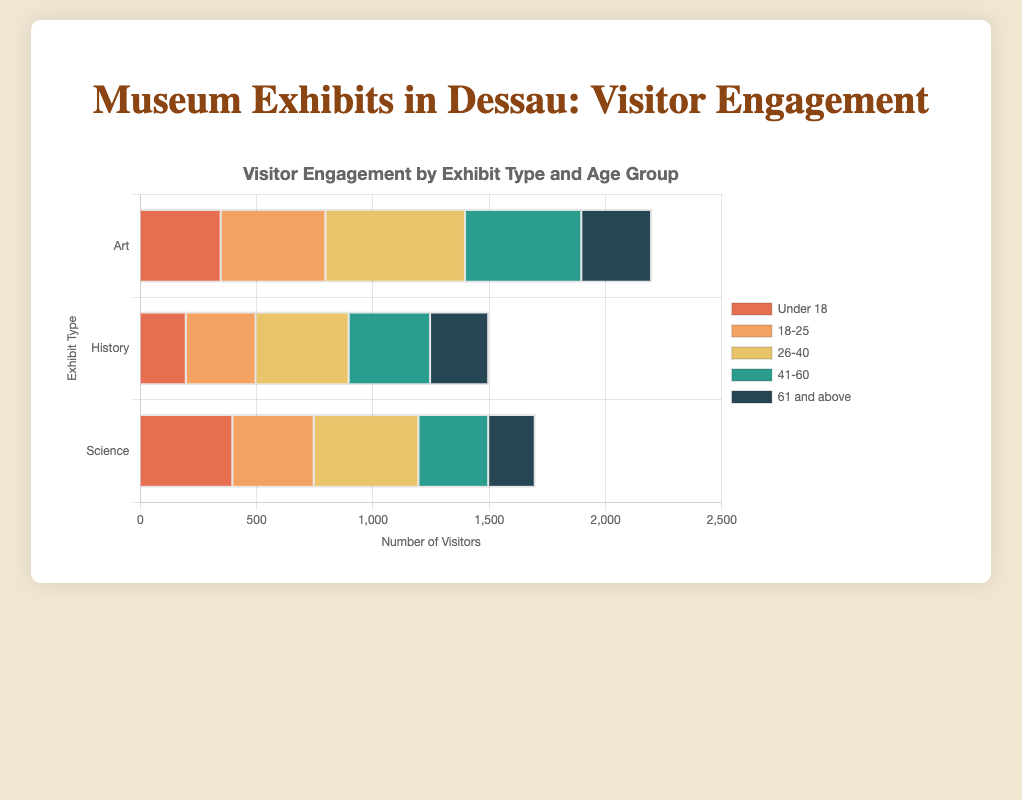What exhibit type has the highest visitor engagement from the '26-40' age group? For the '26-40' age group, compare the visitor numbers for each exhibit type. Art has 600 visitors, History has 400 visitors, and Science has 450 visitors. Therefore, Art has the highest visitor engagement.
Answer: Art How many visitors in total visited the 'Science' exhibits? Sum up the visitor numbers for all age groups in the Science category: 400 (Under 18) + 350 (18-25) + 450 (26-40) + 300 (41-60) + 200 (61 and above) = 1700 visitors.
Answer: 1700 Which exhibit type attracts the most visitors aged '61 and above'? Compare the visitor numbers for the '61 and above' age group across all exhibit types. Art has 300 visitors, History has 250 visitors, and Science has 200 visitors. Art has the most visitors.
Answer: Art What is the total number of visitors for the 'Under 18' age group across all exhibit types? Sum the visitor numbers for the 'Under 18' age group in each exhibit: 350 (Art) + 200 (History) + 400 (Science) = 950 visitors.
Answer: 950 Which age group has the lowest visitor engagement in 'History' exhibits? Compare the visitor numbers for each age group in the History category. Under 18 has 200 visitors, 18-25 has 300 visitors, 26-40 has 400 visitors, 41-60 has 350 visitors, and 61 and above has 250 visitors. Therefore, Under 18 has the lowest engagement.
Answer: Under 18 How many more visitors does the '41-60' age group have in 'Art' exhibits compared to 'Science' exhibits? Calculate the difference in the number of visitors between the two exhibit types for the '41-60' age group. Art has 500 visitors and Science has 300 visitors. The difference is 500 - 300 = 200 more visitors in Art.
Answer: 200 Which color represents the '18-25' age group in the chart? Refer to the color legend for the '18-25' age group. The color is orange.
Answer: orange What is the total number of visitors for the 'Art' exhibit type? Sum the visitor numbers for all age groups in the Art category: 350 (Under 18) + 450 (18-25) + 600 (26-40) + 500 (41-60) + 300 (61 and above) = 2200 visitors.
Answer: 2200 Compare the visitor engagement between 'History' and 'Science' exhibits for the '18-25' age group. Which has more visitors, and by how much? Compare the visitor numbers for the 18-25 age group: History has 300 visitors, and Science has 350 visitors. Science has 50 more visitors (350 - 300).
Answer: Science; 50 